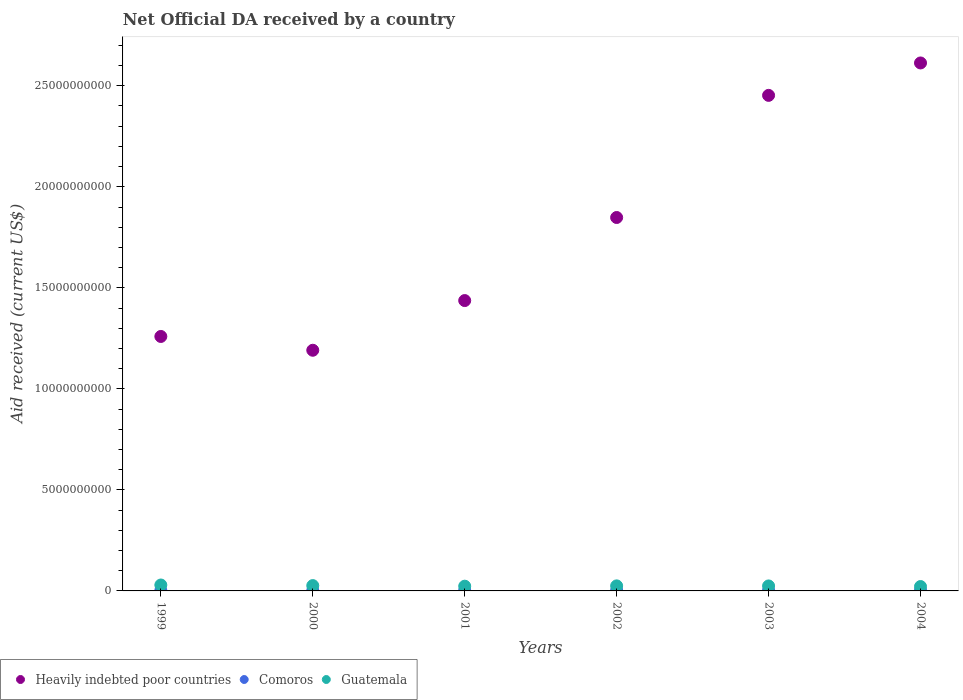How many different coloured dotlines are there?
Offer a very short reply. 3. What is the net official development assistance aid received in Guatemala in 2002?
Your answer should be compact. 2.50e+08. Across all years, what is the maximum net official development assistance aid received in Guatemala?
Keep it short and to the point. 2.93e+08. Across all years, what is the minimum net official development assistance aid received in Heavily indebted poor countries?
Your answer should be compact. 1.19e+1. In which year was the net official development assistance aid received in Heavily indebted poor countries maximum?
Provide a succinct answer. 2004. In which year was the net official development assistance aid received in Guatemala minimum?
Your response must be concise. 2004. What is the total net official development assistance aid received in Guatemala in the graph?
Ensure brevity in your answer.  1.50e+09. What is the difference between the net official development assistance aid received in Comoros in 1999 and that in 2001?
Your answer should be compact. -6.11e+06. What is the difference between the net official development assistance aid received in Comoros in 2004 and the net official development assistance aid received in Guatemala in 2001?
Keep it short and to the point. -2.08e+08. What is the average net official development assistance aid received in Heavily indebted poor countries per year?
Provide a short and direct response. 1.80e+1. In the year 2001, what is the difference between the net official development assistance aid received in Heavily indebted poor countries and net official development assistance aid received in Guatemala?
Provide a short and direct response. 1.41e+1. In how many years, is the net official development assistance aid received in Guatemala greater than 20000000000 US$?
Make the answer very short. 0. What is the ratio of the net official development assistance aid received in Comoros in 2000 to that in 2004?
Provide a succinct answer. 0.71. Is the net official development assistance aid received in Guatemala in 2000 less than that in 2001?
Make the answer very short. No. Is the difference between the net official development assistance aid received in Heavily indebted poor countries in 2000 and 2002 greater than the difference between the net official development assistance aid received in Guatemala in 2000 and 2002?
Your answer should be compact. No. What is the difference between the highest and the second highest net official development assistance aid received in Guatemala?
Your answer should be compact. 3.00e+07. What is the difference between the highest and the lowest net official development assistance aid received in Comoros?
Offer a terse response. 8.87e+06. In how many years, is the net official development assistance aid received in Heavily indebted poor countries greater than the average net official development assistance aid received in Heavily indebted poor countries taken over all years?
Ensure brevity in your answer.  3. Is it the case that in every year, the sum of the net official development assistance aid received in Guatemala and net official development assistance aid received in Heavily indebted poor countries  is greater than the net official development assistance aid received in Comoros?
Your answer should be very brief. Yes. Does the net official development assistance aid received in Heavily indebted poor countries monotonically increase over the years?
Make the answer very short. No. Is the net official development assistance aid received in Comoros strictly less than the net official development assistance aid received in Guatemala over the years?
Ensure brevity in your answer.  Yes. What is the difference between two consecutive major ticks on the Y-axis?
Offer a very short reply. 5.00e+09. Are the values on the major ticks of Y-axis written in scientific E-notation?
Make the answer very short. No. Does the graph contain any zero values?
Your answer should be compact. No. Does the graph contain grids?
Offer a very short reply. No. What is the title of the graph?
Give a very brief answer. Net Official DA received by a country. What is the label or title of the Y-axis?
Give a very brief answer. Aid received (current US$). What is the Aid received (current US$) of Heavily indebted poor countries in 1999?
Your answer should be compact. 1.26e+1. What is the Aid received (current US$) in Comoros in 1999?
Ensure brevity in your answer.  2.14e+07. What is the Aid received (current US$) of Guatemala in 1999?
Provide a short and direct response. 2.93e+08. What is the Aid received (current US$) in Heavily indebted poor countries in 2000?
Offer a terse response. 1.19e+1. What is the Aid received (current US$) of Comoros in 2000?
Give a very brief answer. 1.87e+07. What is the Aid received (current US$) of Guatemala in 2000?
Give a very brief answer. 2.63e+08. What is the Aid received (current US$) of Heavily indebted poor countries in 2001?
Provide a succinct answer. 1.44e+1. What is the Aid received (current US$) in Comoros in 2001?
Give a very brief answer. 2.76e+07. What is the Aid received (current US$) in Guatemala in 2001?
Your response must be concise. 2.34e+08. What is the Aid received (current US$) of Heavily indebted poor countries in 2002?
Provide a short and direct response. 1.85e+1. What is the Aid received (current US$) in Comoros in 2002?
Give a very brief answer. 2.76e+07. What is the Aid received (current US$) in Guatemala in 2002?
Provide a short and direct response. 2.50e+08. What is the Aid received (current US$) of Heavily indebted poor countries in 2003?
Provide a succinct answer. 2.45e+1. What is the Aid received (current US$) in Comoros in 2003?
Offer a terse response. 2.45e+07. What is the Aid received (current US$) of Guatemala in 2003?
Offer a terse response. 2.47e+08. What is the Aid received (current US$) of Heavily indebted poor countries in 2004?
Give a very brief answer. 2.61e+1. What is the Aid received (current US$) of Comoros in 2004?
Your answer should be compact. 2.63e+07. What is the Aid received (current US$) of Guatemala in 2004?
Provide a succinct answer. 2.17e+08. Across all years, what is the maximum Aid received (current US$) of Heavily indebted poor countries?
Offer a very short reply. 2.61e+1. Across all years, what is the maximum Aid received (current US$) of Comoros?
Offer a terse response. 2.76e+07. Across all years, what is the maximum Aid received (current US$) of Guatemala?
Your answer should be very brief. 2.93e+08. Across all years, what is the minimum Aid received (current US$) in Heavily indebted poor countries?
Keep it short and to the point. 1.19e+1. Across all years, what is the minimum Aid received (current US$) of Comoros?
Provide a succinct answer. 1.87e+07. Across all years, what is the minimum Aid received (current US$) of Guatemala?
Offer a terse response. 2.17e+08. What is the total Aid received (current US$) of Heavily indebted poor countries in the graph?
Your response must be concise. 1.08e+11. What is the total Aid received (current US$) in Comoros in the graph?
Offer a very short reply. 1.46e+08. What is the total Aid received (current US$) of Guatemala in the graph?
Provide a short and direct response. 1.50e+09. What is the difference between the Aid received (current US$) in Heavily indebted poor countries in 1999 and that in 2000?
Your response must be concise. 6.83e+08. What is the difference between the Aid received (current US$) in Comoros in 1999 and that in 2000?
Offer a terse response. 2.74e+06. What is the difference between the Aid received (current US$) in Guatemala in 1999 and that in 2000?
Your response must be concise. 3.00e+07. What is the difference between the Aid received (current US$) of Heavily indebted poor countries in 1999 and that in 2001?
Your answer should be very brief. -1.78e+09. What is the difference between the Aid received (current US$) in Comoros in 1999 and that in 2001?
Keep it short and to the point. -6.11e+06. What is the difference between the Aid received (current US$) in Guatemala in 1999 and that in 2001?
Your response must be concise. 5.88e+07. What is the difference between the Aid received (current US$) in Heavily indebted poor countries in 1999 and that in 2002?
Offer a terse response. -5.89e+09. What is the difference between the Aid received (current US$) in Comoros in 1999 and that in 2002?
Make the answer very short. -6.13e+06. What is the difference between the Aid received (current US$) of Guatemala in 1999 and that in 2002?
Your response must be concise. 4.36e+07. What is the difference between the Aid received (current US$) of Heavily indebted poor countries in 1999 and that in 2003?
Make the answer very short. -1.19e+1. What is the difference between the Aid received (current US$) in Comoros in 1999 and that in 2003?
Your answer should be very brief. -3.09e+06. What is the difference between the Aid received (current US$) of Guatemala in 1999 and that in 2003?
Your answer should be very brief. 4.64e+07. What is the difference between the Aid received (current US$) of Heavily indebted poor countries in 1999 and that in 2004?
Your answer should be very brief. -1.35e+1. What is the difference between the Aid received (current US$) in Comoros in 1999 and that in 2004?
Make the answer very short. -4.87e+06. What is the difference between the Aid received (current US$) in Guatemala in 1999 and that in 2004?
Offer a terse response. 7.60e+07. What is the difference between the Aid received (current US$) of Heavily indebted poor countries in 2000 and that in 2001?
Your response must be concise. -2.46e+09. What is the difference between the Aid received (current US$) of Comoros in 2000 and that in 2001?
Provide a succinct answer. -8.85e+06. What is the difference between the Aid received (current US$) in Guatemala in 2000 and that in 2001?
Provide a succinct answer. 2.88e+07. What is the difference between the Aid received (current US$) in Heavily indebted poor countries in 2000 and that in 2002?
Your answer should be very brief. -6.57e+09. What is the difference between the Aid received (current US$) in Comoros in 2000 and that in 2002?
Make the answer very short. -8.87e+06. What is the difference between the Aid received (current US$) of Guatemala in 2000 and that in 2002?
Give a very brief answer. 1.36e+07. What is the difference between the Aid received (current US$) in Heavily indebted poor countries in 2000 and that in 2003?
Your response must be concise. -1.26e+1. What is the difference between the Aid received (current US$) in Comoros in 2000 and that in 2003?
Ensure brevity in your answer.  -5.83e+06. What is the difference between the Aid received (current US$) in Guatemala in 2000 and that in 2003?
Offer a very short reply. 1.64e+07. What is the difference between the Aid received (current US$) of Heavily indebted poor countries in 2000 and that in 2004?
Your response must be concise. -1.42e+1. What is the difference between the Aid received (current US$) in Comoros in 2000 and that in 2004?
Your answer should be very brief. -7.61e+06. What is the difference between the Aid received (current US$) in Guatemala in 2000 and that in 2004?
Your answer should be compact. 4.60e+07. What is the difference between the Aid received (current US$) of Heavily indebted poor countries in 2001 and that in 2002?
Your answer should be compact. -4.11e+09. What is the difference between the Aid received (current US$) in Comoros in 2001 and that in 2002?
Ensure brevity in your answer.  -2.00e+04. What is the difference between the Aid received (current US$) in Guatemala in 2001 and that in 2002?
Your answer should be very brief. -1.52e+07. What is the difference between the Aid received (current US$) in Heavily indebted poor countries in 2001 and that in 2003?
Make the answer very short. -1.02e+1. What is the difference between the Aid received (current US$) in Comoros in 2001 and that in 2003?
Ensure brevity in your answer.  3.02e+06. What is the difference between the Aid received (current US$) in Guatemala in 2001 and that in 2003?
Your answer should be compact. -1.25e+07. What is the difference between the Aid received (current US$) in Heavily indebted poor countries in 2001 and that in 2004?
Keep it short and to the point. -1.18e+1. What is the difference between the Aid received (current US$) of Comoros in 2001 and that in 2004?
Offer a terse response. 1.24e+06. What is the difference between the Aid received (current US$) of Guatemala in 2001 and that in 2004?
Provide a short and direct response. 1.72e+07. What is the difference between the Aid received (current US$) of Heavily indebted poor countries in 2002 and that in 2003?
Offer a very short reply. -6.04e+09. What is the difference between the Aid received (current US$) in Comoros in 2002 and that in 2003?
Keep it short and to the point. 3.04e+06. What is the difference between the Aid received (current US$) of Guatemala in 2002 and that in 2003?
Your answer should be compact. 2.77e+06. What is the difference between the Aid received (current US$) in Heavily indebted poor countries in 2002 and that in 2004?
Make the answer very short. -7.65e+09. What is the difference between the Aid received (current US$) of Comoros in 2002 and that in 2004?
Give a very brief answer. 1.26e+06. What is the difference between the Aid received (current US$) of Guatemala in 2002 and that in 2004?
Your response must be concise. 3.24e+07. What is the difference between the Aid received (current US$) of Heavily indebted poor countries in 2003 and that in 2004?
Provide a succinct answer. -1.60e+09. What is the difference between the Aid received (current US$) in Comoros in 2003 and that in 2004?
Your answer should be very brief. -1.78e+06. What is the difference between the Aid received (current US$) in Guatemala in 2003 and that in 2004?
Provide a short and direct response. 2.97e+07. What is the difference between the Aid received (current US$) in Heavily indebted poor countries in 1999 and the Aid received (current US$) in Comoros in 2000?
Provide a short and direct response. 1.26e+1. What is the difference between the Aid received (current US$) of Heavily indebted poor countries in 1999 and the Aid received (current US$) of Guatemala in 2000?
Your answer should be very brief. 1.23e+1. What is the difference between the Aid received (current US$) in Comoros in 1999 and the Aid received (current US$) in Guatemala in 2000?
Give a very brief answer. -2.42e+08. What is the difference between the Aid received (current US$) in Heavily indebted poor countries in 1999 and the Aid received (current US$) in Comoros in 2001?
Your answer should be compact. 1.26e+1. What is the difference between the Aid received (current US$) of Heavily indebted poor countries in 1999 and the Aid received (current US$) of Guatemala in 2001?
Provide a succinct answer. 1.24e+1. What is the difference between the Aid received (current US$) in Comoros in 1999 and the Aid received (current US$) in Guatemala in 2001?
Offer a very short reply. -2.13e+08. What is the difference between the Aid received (current US$) of Heavily indebted poor countries in 1999 and the Aid received (current US$) of Comoros in 2002?
Your response must be concise. 1.26e+1. What is the difference between the Aid received (current US$) of Heavily indebted poor countries in 1999 and the Aid received (current US$) of Guatemala in 2002?
Your response must be concise. 1.23e+1. What is the difference between the Aid received (current US$) in Comoros in 1999 and the Aid received (current US$) in Guatemala in 2002?
Your response must be concise. -2.28e+08. What is the difference between the Aid received (current US$) of Heavily indebted poor countries in 1999 and the Aid received (current US$) of Comoros in 2003?
Your answer should be very brief. 1.26e+1. What is the difference between the Aid received (current US$) of Heavily indebted poor countries in 1999 and the Aid received (current US$) of Guatemala in 2003?
Provide a succinct answer. 1.23e+1. What is the difference between the Aid received (current US$) of Comoros in 1999 and the Aid received (current US$) of Guatemala in 2003?
Your response must be concise. -2.25e+08. What is the difference between the Aid received (current US$) of Heavily indebted poor countries in 1999 and the Aid received (current US$) of Comoros in 2004?
Your response must be concise. 1.26e+1. What is the difference between the Aid received (current US$) of Heavily indebted poor countries in 1999 and the Aid received (current US$) of Guatemala in 2004?
Make the answer very short. 1.24e+1. What is the difference between the Aid received (current US$) of Comoros in 1999 and the Aid received (current US$) of Guatemala in 2004?
Your answer should be compact. -1.96e+08. What is the difference between the Aid received (current US$) of Heavily indebted poor countries in 2000 and the Aid received (current US$) of Comoros in 2001?
Offer a terse response. 1.19e+1. What is the difference between the Aid received (current US$) of Heavily indebted poor countries in 2000 and the Aid received (current US$) of Guatemala in 2001?
Offer a very short reply. 1.17e+1. What is the difference between the Aid received (current US$) of Comoros in 2000 and the Aid received (current US$) of Guatemala in 2001?
Provide a short and direct response. -2.16e+08. What is the difference between the Aid received (current US$) of Heavily indebted poor countries in 2000 and the Aid received (current US$) of Comoros in 2002?
Offer a very short reply. 1.19e+1. What is the difference between the Aid received (current US$) in Heavily indebted poor countries in 2000 and the Aid received (current US$) in Guatemala in 2002?
Ensure brevity in your answer.  1.17e+1. What is the difference between the Aid received (current US$) in Comoros in 2000 and the Aid received (current US$) in Guatemala in 2002?
Make the answer very short. -2.31e+08. What is the difference between the Aid received (current US$) in Heavily indebted poor countries in 2000 and the Aid received (current US$) in Comoros in 2003?
Your answer should be very brief. 1.19e+1. What is the difference between the Aid received (current US$) in Heavily indebted poor countries in 2000 and the Aid received (current US$) in Guatemala in 2003?
Offer a terse response. 1.17e+1. What is the difference between the Aid received (current US$) of Comoros in 2000 and the Aid received (current US$) of Guatemala in 2003?
Ensure brevity in your answer.  -2.28e+08. What is the difference between the Aid received (current US$) in Heavily indebted poor countries in 2000 and the Aid received (current US$) in Comoros in 2004?
Ensure brevity in your answer.  1.19e+1. What is the difference between the Aid received (current US$) in Heavily indebted poor countries in 2000 and the Aid received (current US$) in Guatemala in 2004?
Offer a very short reply. 1.17e+1. What is the difference between the Aid received (current US$) of Comoros in 2000 and the Aid received (current US$) of Guatemala in 2004?
Provide a short and direct response. -1.98e+08. What is the difference between the Aid received (current US$) in Heavily indebted poor countries in 2001 and the Aid received (current US$) in Comoros in 2002?
Offer a very short reply. 1.43e+1. What is the difference between the Aid received (current US$) of Heavily indebted poor countries in 2001 and the Aid received (current US$) of Guatemala in 2002?
Provide a short and direct response. 1.41e+1. What is the difference between the Aid received (current US$) of Comoros in 2001 and the Aid received (current US$) of Guatemala in 2002?
Your answer should be very brief. -2.22e+08. What is the difference between the Aid received (current US$) in Heavily indebted poor countries in 2001 and the Aid received (current US$) in Comoros in 2003?
Make the answer very short. 1.43e+1. What is the difference between the Aid received (current US$) of Heavily indebted poor countries in 2001 and the Aid received (current US$) of Guatemala in 2003?
Your answer should be very brief. 1.41e+1. What is the difference between the Aid received (current US$) of Comoros in 2001 and the Aid received (current US$) of Guatemala in 2003?
Keep it short and to the point. -2.19e+08. What is the difference between the Aid received (current US$) of Heavily indebted poor countries in 2001 and the Aid received (current US$) of Comoros in 2004?
Your answer should be very brief. 1.43e+1. What is the difference between the Aid received (current US$) in Heavily indebted poor countries in 2001 and the Aid received (current US$) in Guatemala in 2004?
Offer a very short reply. 1.42e+1. What is the difference between the Aid received (current US$) of Comoros in 2001 and the Aid received (current US$) of Guatemala in 2004?
Ensure brevity in your answer.  -1.90e+08. What is the difference between the Aid received (current US$) in Heavily indebted poor countries in 2002 and the Aid received (current US$) in Comoros in 2003?
Give a very brief answer. 1.85e+1. What is the difference between the Aid received (current US$) of Heavily indebted poor countries in 2002 and the Aid received (current US$) of Guatemala in 2003?
Your answer should be compact. 1.82e+1. What is the difference between the Aid received (current US$) of Comoros in 2002 and the Aid received (current US$) of Guatemala in 2003?
Provide a short and direct response. -2.19e+08. What is the difference between the Aid received (current US$) of Heavily indebted poor countries in 2002 and the Aid received (current US$) of Comoros in 2004?
Your answer should be compact. 1.85e+1. What is the difference between the Aid received (current US$) in Heavily indebted poor countries in 2002 and the Aid received (current US$) in Guatemala in 2004?
Your response must be concise. 1.83e+1. What is the difference between the Aid received (current US$) in Comoros in 2002 and the Aid received (current US$) in Guatemala in 2004?
Ensure brevity in your answer.  -1.90e+08. What is the difference between the Aid received (current US$) of Heavily indebted poor countries in 2003 and the Aid received (current US$) of Comoros in 2004?
Make the answer very short. 2.45e+1. What is the difference between the Aid received (current US$) of Heavily indebted poor countries in 2003 and the Aid received (current US$) of Guatemala in 2004?
Offer a terse response. 2.43e+1. What is the difference between the Aid received (current US$) of Comoros in 2003 and the Aid received (current US$) of Guatemala in 2004?
Ensure brevity in your answer.  -1.93e+08. What is the average Aid received (current US$) in Heavily indebted poor countries per year?
Make the answer very short. 1.80e+1. What is the average Aid received (current US$) of Comoros per year?
Ensure brevity in your answer.  2.44e+07. What is the average Aid received (current US$) in Guatemala per year?
Your answer should be compact. 2.51e+08. In the year 1999, what is the difference between the Aid received (current US$) of Heavily indebted poor countries and Aid received (current US$) of Comoros?
Your answer should be compact. 1.26e+1. In the year 1999, what is the difference between the Aid received (current US$) in Heavily indebted poor countries and Aid received (current US$) in Guatemala?
Offer a terse response. 1.23e+1. In the year 1999, what is the difference between the Aid received (current US$) of Comoros and Aid received (current US$) of Guatemala?
Make the answer very short. -2.72e+08. In the year 2000, what is the difference between the Aid received (current US$) of Heavily indebted poor countries and Aid received (current US$) of Comoros?
Ensure brevity in your answer.  1.19e+1. In the year 2000, what is the difference between the Aid received (current US$) in Heavily indebted poor countries and Aid received (current US$) in Guatemala?
Make the answer very short. 1.16e+1. In the year 2000, what is the difference between the Aid received (current US$) of Comoros and Aid received (current US$) of Guatemala?
Provide a short and direct response. -2.44e+08. In the year 2001, what is the difference between the Aid received (current US$) of Heavily indebted poor countries and Aid received (current US$) of Comoros?
Give a very brief answer. 1.43e+1. In the year 2001, what is the difference between the Aid received (current US$) in Heavily indebted poor countries and Aid received (current US$) in Guatemala?
Give a very brief answer. 1.41e+1. In the year 2001, what is the difference between the Aid received (current US$) in Comoros and Aid received (current US$) in Guatemala?
Give a very brief answer. -2.07e+08. In the year 2002, what is the difference between the Aid received (current US$) of Heavily indebted poor countries and Aid received (current US$) of Comoros?
Make the answer very short. 1.85e+1. In the year 2002, what is the difference between the Aid received (current US$) in Heavily indebted poor countries and Aid received (current US$) in Guatemala?
Offer a very short reply. 1.82e+1. In the year 2002, what is the difference between the Aid received (current US$) in Comoros and Aid received (current US$) in Guatemala?
Provide a short and direct response. -2.22e+08. In the year 2003, what is the difference between the Aid received (current US$) in Heavily indebted poor countries and Aid received (current US$) in Comoros?
Provide a short and direct response. 2.45e+1. In the year 2003, what is the difference between the Aid received (current US$) of Heavily indebted poor countries and Aid received (current US$) of Guatemala?
Offer a terse response. 2.43e+1. In the year 2003, what is the difference between the Aid received (current US$) of Comoros and Aid received (current US$) of Guatemala?
Ensure brevity in your answer.  -2.22e+08. In the year 2004, what is the difference between the Aid received (current US$) in Heavily indebted poor countries and Aid received (current US$) in Comoros?
Provide a short and direct response. 2.61e+1. In the year 2004, what is the difference between the Aid received (current US$) of Heavily indebted poor countries and Aid received (current US$) of Guatemala?
Give a very brief answer. 2.59e+1. In the year 2004, what is the difference between the Aid received (current US$) in Comoros and Aid received (current US$) in Guatemala?
Give a very brief answer. -1.91e+08. What is the ratio of the Aid received (current US$) of Heavily indebted poor countries in 1999 to that in 2000?
Your answer should be compact. 1.06. What is the ratio of the Aid received (current US$) of Comoros in 1999 to that in 2000?
Offer a terse response. 1.15. What is the ratio of the Aid received (current US$) in Guatemala in 1999 to that in 2000?
Offer a very short reply. 1.11. What is the ratio of the Aid received (current US$) in Heavily indebted poor countries in 1999 to that in 2001?
Your response must be concise. 0.88. What is the ratio of the Aid received (current US$) in Comoros in 1999 to that in 2001?
Make the answer very short. 0.78. What is the ratio of the Aid received (current US$) of Guatemala in 1999 to that in 2001?
Give a very brief answer. 1.25. What is the ratio of the Aid received (current US$) of Heavily indebted poor countries in 1999 to that in 2002?
Provide a short and direct response. 0.68. What is the ratio of the Aid received (current US$) of Comoros in 1999 to that in 2002?
Keep it short and to the point. 0.78. What is the ratio of the Aid received (current US$) in Guatemala in 1999 to that in 2002?
Make the answer very short. 1.17. What is the ratio of the Aid received (current US$) in Heavily indebted poor countries in 1999 to that in 2003?
Your answer should be very brief. 0.51. What is the ratio of the Aid received (current US$) in Comoros in 1999 to that in 2003?
Your answer should be compact. 0.87. What is the ratio of the Aid received (current US$) of Guatemala in 1999 to that in 2003?
Make the answer very short. 1.19. What is the ratio of the Aid received (current US$) of Heavily indebted poor countries in 1999 to that in 2004?
Provide a short and direct response. 0.48. What is the ratio of the Aid received (current US$) of Comoros in 1999 to that in 2004?
Your answer should be very brief. 0.81. What is the ratio of the Aid received (current US$) in Guatemala in 1999 to that in 2004?
Ensure brevity in your answer.  1.35. What is the ratio of the Aid received (current US$) of Heavily indebted poor countries in 2000 to that in 2001?
Your answer should be compact. 0.83. What is the ratio of the Aid received (current US$) in Comoros in 2000 to that in 2001?
Your response must be concise. 0.68. What is the ratio of the Aid received (current US$) in Guatemala in 2000 to that in 2001?
Give a very brief answer. 1.12. What is the ratio of the Aid received (current US$) of Heavily indebted poor countries in 2000 to that in 2002?
Provide a succinct answer. 0.64. What is the ratio of the Aid received (current US$) in Comoros in 2000 to that in 2002?
Your answer should be compact. 0.68. What is the ratio of the Aid received (current US$) of Guatemala in 2000 to that in 2002?
Your answer should be compact. 1.05. What is the ratio of the Aid received (current US$) of Heavily indebted poor countries in 2000 to that in 2003?
Your response must be concise. 0.49. What is the ratio of the Aid received (current US$) of Comoros in 2000 to that in 2003?
Offer a very short reply. 0.76. What is the ratio of the Aid received (current US$) of Guatemala in 2000 to that in 2003?
Offer a terse response. 1.07. What is the ratio of the Aid received (current US$) in Heavily indebted poor countries in 2000 to that in 2004?
Your response must be concise. 0.46. What is the ratio of the Aid received (current US$) of Comoros in 2000 to that in 2004?
Your response must be concise. 0.71. What is the ratio of the Aid received (current US$) in Guatemala in 2000 to that in 2004?
Make the answer very short. 1.21. What is the ratio of the Aid received (current US$) of Heavily indebted poor countries in 2001 to that in 2002?
Keep it short and to the point. 0.78. What is the ratio of the Aid received (current US$) in Comoros in 2001 to that in 2002?
Make the answer very short. 1. What is the ratio of the Aid received (current US$) in Guatemala in 2001 to that in 2002?
Keep it short and to the point. 0.94. What is the ratio of the Aid received (current US$) of Heavily indebted poor countries in 2001 to that in 2003?
Make the answer very short. 0.59. What is the ratio of the Aid received (current US$) of Comoros in 2001 to that in 2003?
Your answer should be very brief. 1.12. What is the ratio of the Aid received (current US$) of Guatemala in 2001 to that in 2003?
Provide a short and direct response. 0.95. What is the ratio of the Aid received (current US$) of Heavily indebted poor countries in 2001 to that in 2004?
Offer a very short reply. 0.55. What is the ratio of the Aid received (current US$) of Comoros in 2001 to that in 2004?
Keep it short and to the point. 1.05. What is the ratio of the Aid received (current US$) of Guatemala in 2001 to that in 2004?
Provide a short and direct response. 1.08. What is the ratio of the Aid received (current US$) in Heavily indebted poor countries in 2002 to that in 2003?
Your answer should be very brief. 0.75. What is the ratio of the Aid received (current US$) in Comoros in 2002 to that in 2003?
Ensure brevity in your answer.  1.12. What is the ratio of the Aid received (current US$) of Guatemala in 2002 to that in 2003?
Make the answer very short. 1.01. What is the ratio of the Aid received (current US$) of Heavily indebted poor countries in 2002 to that in 2004?
Keep it short and to the point. 0.71. What is the ratio of the Aid received (current US$) of Comoros in 2002 to that in 2004?
Provide a succinct answer. 1.05. What is the ratio of the Aid received (current US$) of Guatemala in 2002 to that in 2004?
Your response must be concise. 1.15. What is the ratio of the Aid received (current US$) of Heavily indebted poor countries in 2003 to that in 2004?
Provide a succinct answer. 0.94. What is the ratio of the Aid received (current US$) of Comoros in 2003 to that in 2004?
Make the answer very short. 0.93. What is the ratio of the Aid received (current US$) in Guatemala in 2003 to that in 2004?
Provide a succinct answer. 1.14. What is the difference between the highest and the second highest Aid received (current US$) in Heavily indebted poor countries?
Your answer should be compact. 1.60e+09. What is the difference between the highest and the second highest Aid received (current US$) of Comoros?
Provide a succinct answer. 2.00e+04. What is the difference between the highest and the second highest Aid received (current US$) of Guatemala?
Your response must be concise. 3.00e+07. What is the difference between the highest and the lowest Aid received (current US$) of Heavily indebted poor countries?
Ensure brevity in your answer.  1.42e+1. What is the difference between the highest and the lowest Aid received (current US$) in Comoros?
Your answer should be compact. 8.87e+06. What is the difference between the highest and the lowest Aid received (current US$) of Guatemala?
Your answer should be compact. 7.60e+07. 